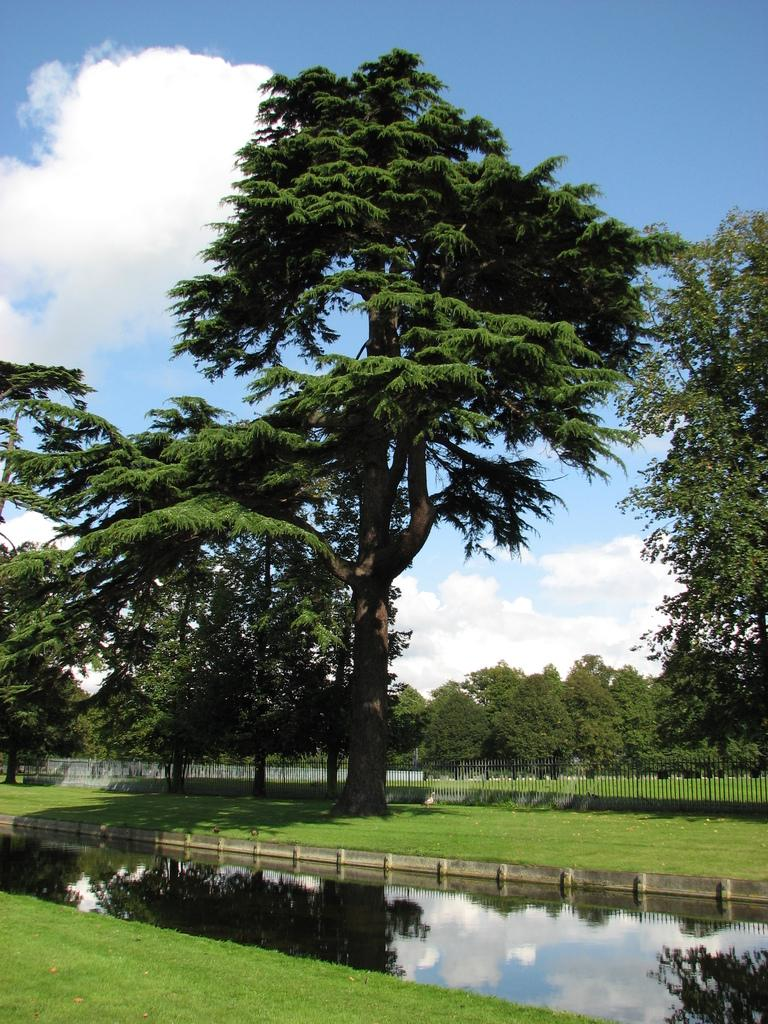What is covering the ground in the image? There is water and grass visible on the ground in the image. What type of natural barrier can be seen in the background of the image? There is a fence in the background of the image. What other natural elements are present in the background of the image? There are trees in the background of the image. What is visible in the sky in the image? The sky is visible in the background of the image, and it contains clouds. What type of canvas is being used by the company to create the sweater in the image? There is no canvas, company, or sweater present in the image. 